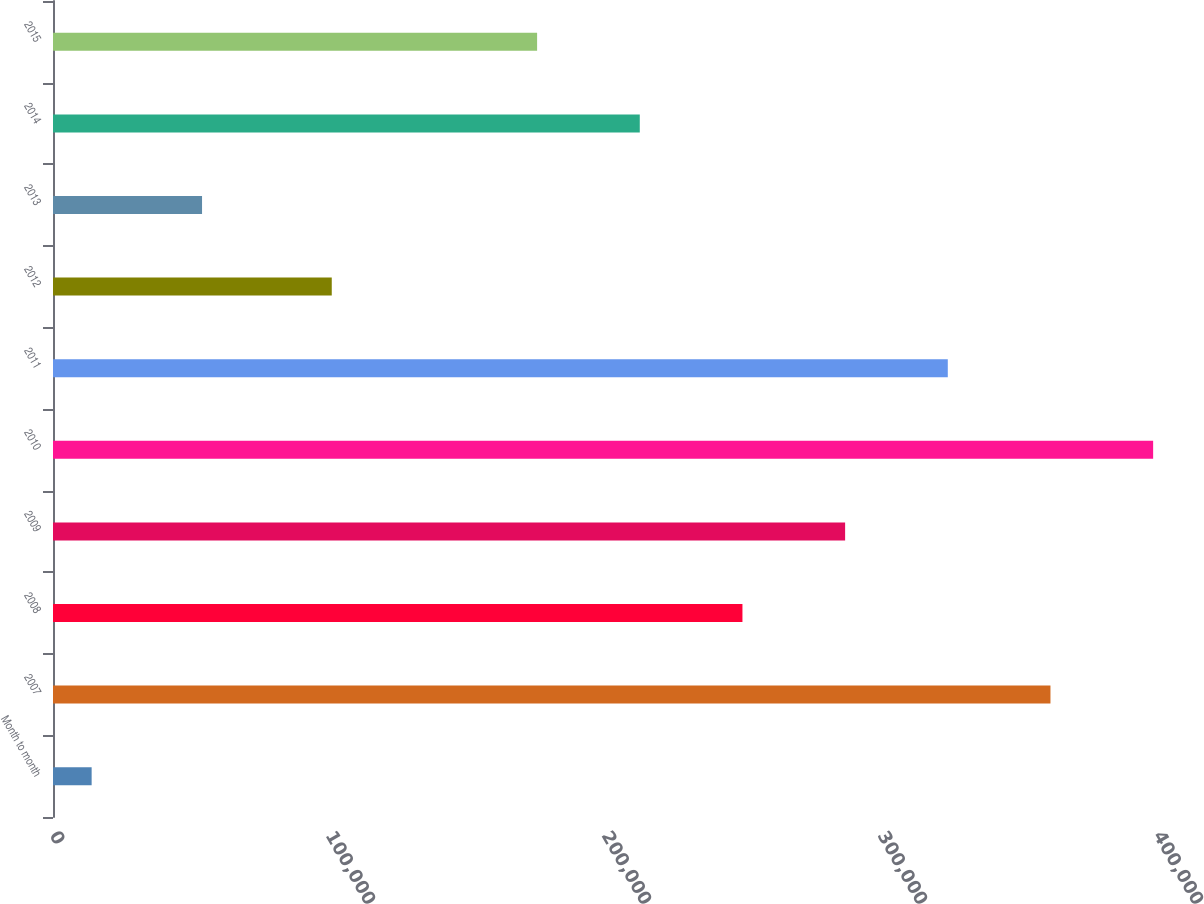<chart> <loc_0><loc_0><loc_500><loc_500><bar_chart><fcel>Month to month<fcel>2007<fcel>2008<fcel>2009<fcel>2010<fcel>2011<fcel>2012<fcel>2013<fcel>2014<fcel>2015<nl><fcel>14000<fcel>361400<fcel>249800<fcel>287000<fcel>398600<fcel>324200<fcel>101000<fcel>54000<fcel>212600<fcel>175400<nl></chart> 